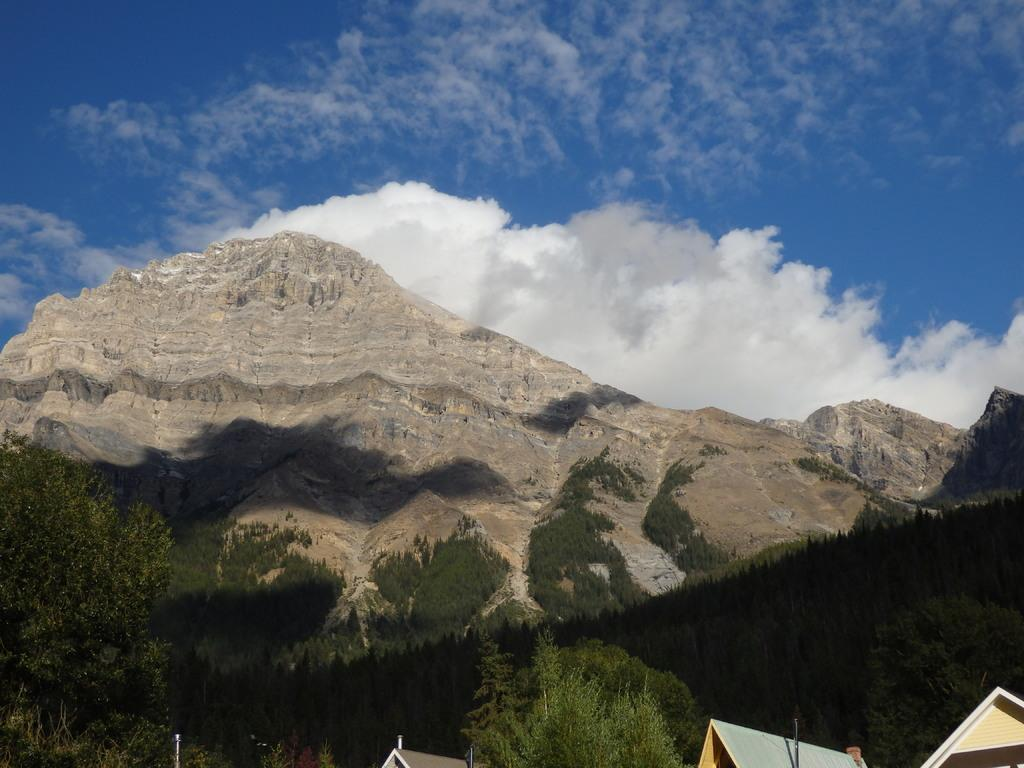What type of natural elements can be seen in the image? There are trees and hills visible in the image. What type of man-made structures can be seen in the image? There are rooftops visible in the image. What is visible in the background of the image? The sky is visible in the background of the image. What can be observed in the sky in the image? Clouds are present in the sky. How many girls are sitting on the ground in the image? There are no girls present in the image. What type of jam is being used to decorate the rooftops in the image? There is no jam present in the image; it features trees, hills, rooftops, and clouds in the sky. 